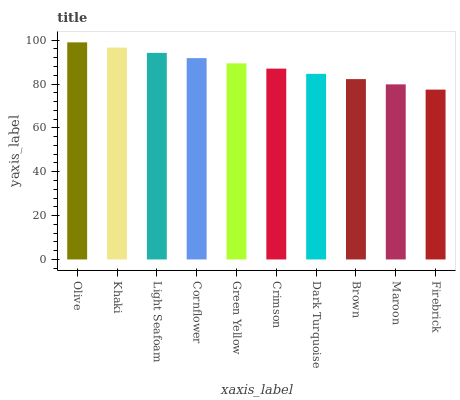Is Khaki the minimum?
Answer yes or no. No. Is Khaki the maximum?
Answer yes or no. No. Is Olive greater than Khaki?
Answer yes or no. Yes. Is Khaki less than Olive?
Answer yes or no. Yes. Is Khaki greater than Olive?
Answer yes or no. No. Is Olive less than Khaki?
Answer yes or no. No. Is Green Yellow the high median?
Answer yes or no. Yes. Is Crimson the low median?
Answer yes or no. Yes. Is Cornflower the high median?
Answer yes or no. No. Is Maroon the low median?
Answer yes or no. No. 